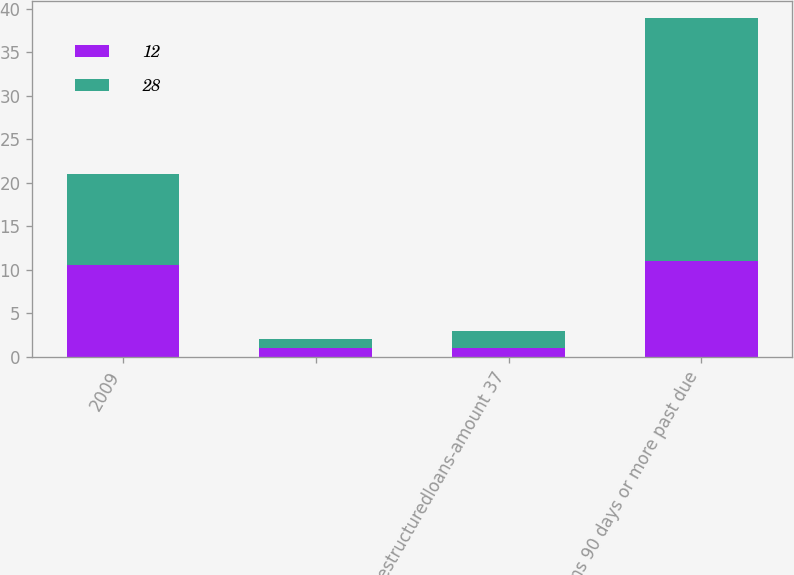<chart> <loc_0><loc_0><loc_500><loc_500><stacked_bar_chart><ecel><fcel>2009<fcel>Unnamed: 2<fcel>Restructuredloans-amount 37<fcel>Loans 90 days or more past due<nl><fcel>12<fcel>10.5<fcel>1<fcel>1<fcel>11<nl><fcel>28<fcel>10.5<fcel>1<fcel>2<fcel>28<nl></chart> 